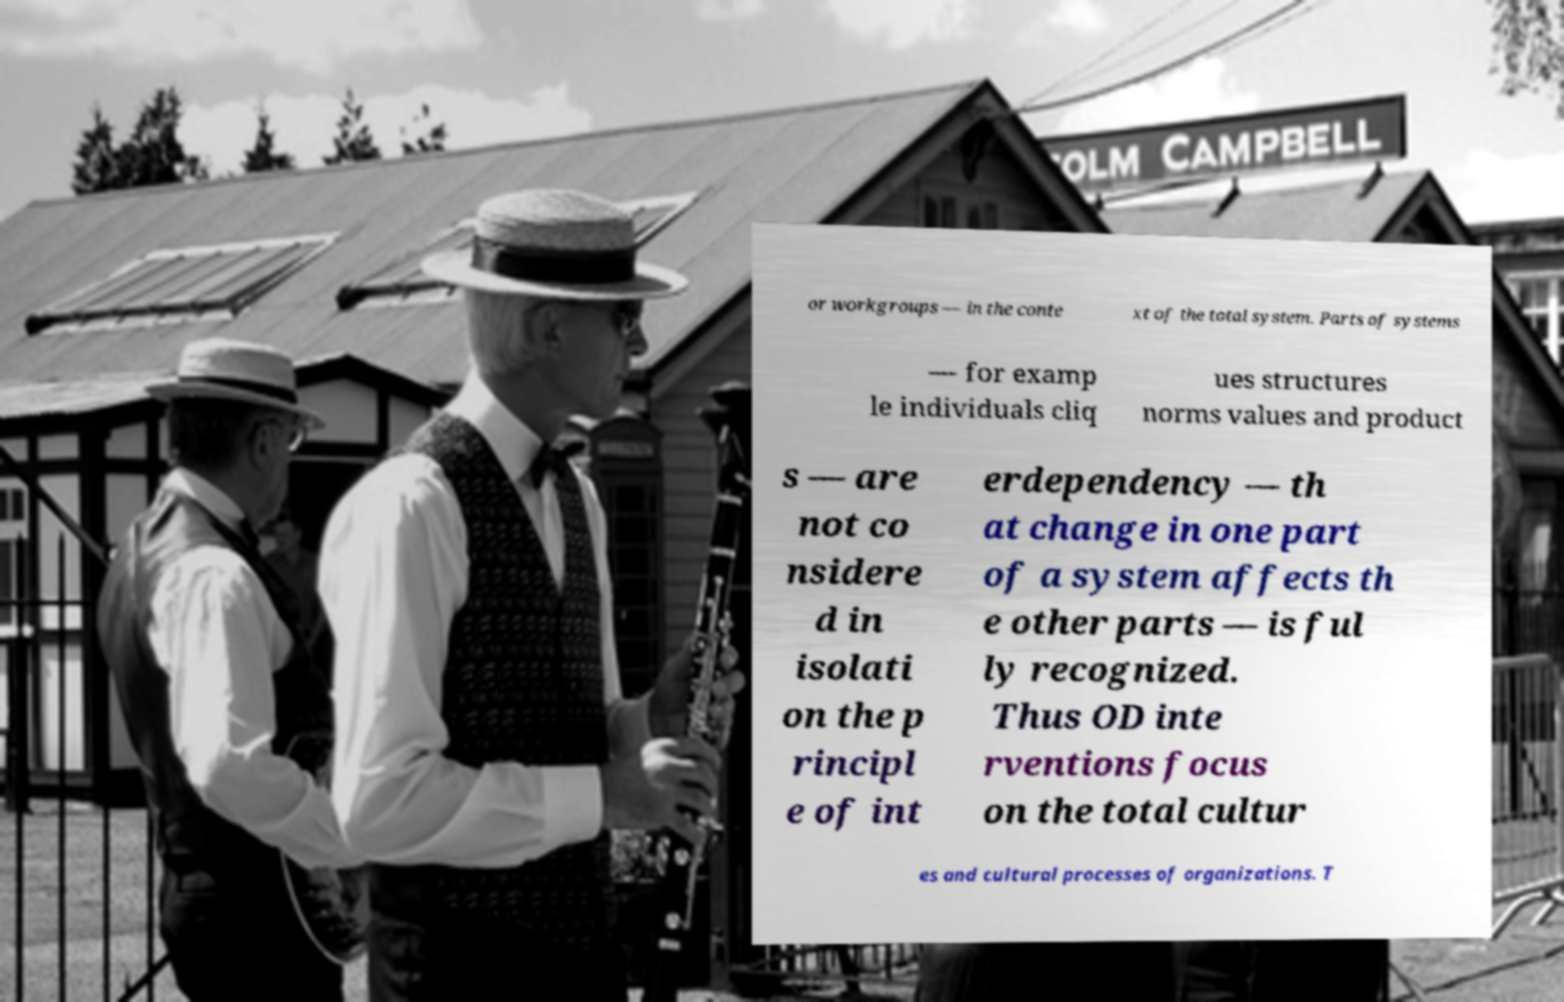Please read and relay the text visible in this image. What does it say? or workgroups — in the conte xt of the total system. Parts of systems — for examp le individuals cliq ues structures norms values and product s — are not co nsidere d in isolati on the p rincipl e of int erdependency — th at change in one part of a system affects th e other parts — is ful ly recognized. Thus OD inte rventions focus on the total cultur es and cultural processes of organizations. T 